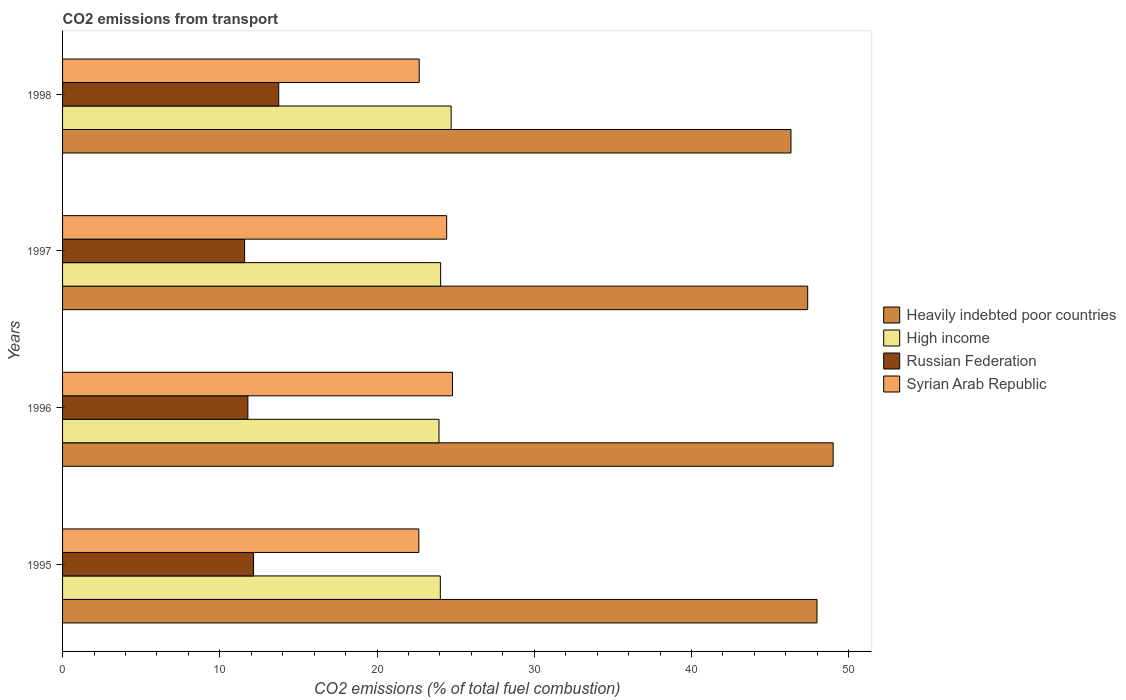How many different coloured bars are there?
Give a very brief answer. 4. Are the number of bars per tick equal to the number of legend labels?
Ensure brevity in your answer.  Yes. Are the number of bars on each tick of the Y-axis equal?
Your answer should be very brief. Yes. What is the label of the 4th group of bars from the top?
Give a very brief answer. 1995. In how many cases, is the number of bars for a given year not equal to the number of legend labels?
Keep it short and to the point. 0. What is the total CO2 emitted in Russian Federation in 1997?
Your answer should be compact. 11.58. Across all years, what is the maximum total CO2 emitted in Russian Federation?
Give a very brief answer. 13.75. Across all years, what is the minimum total CO2 emitted in Syrian Arab Republic?
Your answer should be compact. 22.66. In which year was the total CO2 emitted in High income maximum?
Offer a terse response. 1998. What is the total total CO2 emitted in High income in the graph?
Ensure brevity in your answer.  96.73. What is the difference between the total CO2 emitted in High income in 1995 and that in 1997?
Ensure brevity in your answer.  -0.02. What is the difference between the total CO2 emitted in Syrian Arab Republic in 1998 and the total CO2 emitted in High income in 1995?
Keep it short and to the point. -1.34. What is the average total CO2 emitted in Heavily indebted poor countries per year?
Ensure brevity in your answer.  47.68. In the year 1995, what is the difference between the total CO2 emitted in Syrian Arab Republic and total CO2 emitted in Heavily indebted poor countries?
Ensure brevity in your answer.  -25.33. In how many years, is the total CO2 emitted in Russian Federation greater than 30 ?
Your answer should be compact. 0. What is the ratio of the total CO2 emitted in Syrian Arab Republic in 1995 to that in 1998?
Provide a short and direct response. 1. Is the total CO2 emitted in High income in 1995 less than that in 1996?
Make the answer very short. No. What is the difference between the highest and the second highest total CO2 emitted in High income?
Your response must be concise. 0.67. What is the difference between the highest and the lowest total CO2 emitted in Russian Federation?
Offer a very short reply. 2.17. In how many years, is the total CO2 emitted in Syrian Arab Republic greater than the average total CO2 emitted in Syrian Arab Republic taken over all years?
Provide a succinct answer. 2. Is the sum of the total CO2 emitted in Syrian Arab Republic in 1995 and 1998 greater than the maximum total CO2 emitted in Heavily indebted poor countries across all years?
Make the answer very short. No. What does the 4th bar from the top in 1998 represents?
Your answer should be very brief. Heavily indebted poor countries. What does the 4th bar from the bottom in 1998 represents?
Offer a terse response. Syrian Arab Republic. How many bars are there?
Your response must be concise. 16. Are all the bars in the graph horizontal?
Give a very brief answer. Yes. Are the values on the major ticks of X-axis written in scientific E-notation?
Provide a short and direct response. No. Does the graph contain any zero values?
Ensure brevity in your answer.  No. Does the graph contain grids?
Give a very brief answer. No. Where does the legend appear in the graph?
Keep it short and to the point. Center right. How many legend labels are there?
Your answer should be compact. 4. How are the legend labels stacked?
Keep it short and to the point. Vertical. What is the title of the graph?
Keep it short and to the point. CO2 emissions from transport. Does "Guam" appear as one of the legend labels in the graph?
Provide a short and direct response. No. What is the label or title of the X-axis?
Keep it short and to the point. CO2 emissions (% of total fuel combustion). What is the CO2 emissions (% of total fuel combustion) of Heavily indebted poor countries in 1995?
Provide a short and direct response. 47.99. What is the CO2 emissions (% of total fuel combustion) in High income in 1995?
Your response must be concise. 24.03. What is the CO2 emissions (% of total fuel combustion) of Russian Federation in 1995?
Offer a very short reply. 12.15. What is the CO2 emissions (% of total fuel combustion) in Syrian Arab Republic in 1995?
Offer a terse response. 22.66. What is the CO2 emissions (% of total fuel combustion) of Heavily indebted poor countries in 1996?
Provide a succinct answer. 49.01. What is the CO2 emissions (% of total fuel combustion) in High income in 1996?
Keep it short and to the point. 23.94. What is the CO2 emissions (% of total fuel combustion) in Russian Federation in 1996?
Give a very brief answer. 11.79. What is the CO2 emissions (% of total fuel combustion) in Syrian Arab Republic in 1996?
Provide a short and direct response. 24.8. What is the CO2 emissions (% of total fuel combustion) of Heavily indebted poor countries in 1997?
Make the answer very short. 47.39. What is the CO2 emissions (% of total fuel combustion) in High income in 1997?
Provide a succinct answer. 24.05. What is the CO2 emissions (% of total fuel combustion) of Russian Federation in 1997?
Your answer should be compact. 11.58. What is the CO2 emissions (% of total fuel combustion) in Syrian Arab Republic in 1997?
Keep it short and to the point. 24.43. What is the CO2 emissions (% of total fuel combustion) of Heavily indebted poor countries in 1998?
Offer a very short reply. 46.33. What is the CO2 emissions (% of total fuel combustion) of High income in 1998?
Keep it short and to the point. 24.71. What is the CO2 emissions (% of total fuel combustion) of Russian Federation in 1998?
Provide a succinct answer. 13.75. What is the CO2 emissions (% of total fuel combustion) of Syrian Arab Republic in 1998?
Offer a terse response. 22.68. Across all years, what is the maximum CO2 emissions (% of total fuel combustion) of Heavily indebted poor countries?
Ensure brevity in your answer.  49.01. Across all years, what is the maximum CO2 emissions (% of total fuel combustion) in High income?
Provide a short and direct response. 24.71. Across all years, what is the maximum CO2 emissions (% of total fuel combustion) in Russian Federation?
Your answer should be compact. 13.75. Across all years, what is the maximum CO2 emissions (% of total fuel combustion) in Syrian Arab Republic?
Your answer should be very brief. 24.8. Across all years, what is the minimum CO2 emissions (% of total fuel combustion) in Heavily indebted poor countries?
Your answer should be very brief. 46.33. Across all years, what is the minimum CO2 emissions (% of total fuel combustion) of High income?
Make the answer very short. 23.94. Across all years, what is the minimum CO2 emissions (% of total fuel combustion) in Russian Federation?
Your answer should be compact. 11.58. Across all years, what is the minimum CO2 emissions (% of total fuel combustion) of Syrian Arab Republic?
Ensure brevity in your answer.  22.66. What is the total CO2 emissions (% of total fuel combustion) of Heavily indebted poor countries in the graph?
Give a very brief answer. 190.72. What is the total CO2 emissions (% of total fuel combustion) in High income in the graph?
Your answer should be very brief. 96.73. What is the total CO2 emissions (% of total fuel combustion) in Russian Federation in the graph?
Keep it short and to the point. 49.26. What is the total CO2 emissions (% of total fuel combustion) in Syrian Arab Republic in the graph?
Your response must be concise. 94.58. What is the difference between the CO2 emissions (% of total fuel combustion) of Heavily indebted poor countries in 1995 and that in 1996?
Your response must be concise. -1.03. What is the difference between the CO2 emissions (% of total fuel combustion) of High income in 1995 and that in 1996?
Offer a very short reply. 0.08. What is the difference between the CO2 emissions (% of total fuel combustion) of Russian Federation in 1995 and that in 1996?
Keep it short and to the point. 0.36. What is the difference between the CO2 emissions (% of total fuel combustion) in Syrian Arab Republic in 1995 and that in 1996?
Your answer should be very brief. -2.14. What is the difference between the CO2 emissions (% of total fuel combustion) of Heavily indebted poor countries in 1995 and that in 1997?
Offer a terse response. 0.59. What is the difference between the CO2 emissions (% of total fuel combustion) in High income in 1995 and that in 1997?
Make the answer very short. -0.02. What is the difference between the CO2 emissions (% of total fuel combustion) of Russian Federation in 1995 and that in 1997?
Give a very brief answer. 0.57. What is the difference between the CO2 emissions (% of total fuel combustion) of Syrian Arab Republic in 1995 and that in 1997?
Make the answer very short. -1.77. What is the difference between the CO2 emissions (% of total fuel combustion) of Heavily indebted poor countries in 1995 and that in 1998?
Your response must be concise. 1.66. What is the difference between the CO2 emissions (% of total fuel combustion) in High income in 1995 and that in 1998?
Give a very brief answer. -0.69. What is the difference between the CO2 emissions (% of total fuel combustion) of Russian Federation in 1995 and that in 1998?
Offer a very short reply. -1.6. What is the difference between the CO2 emissions (% of total fuel combustion) in Syrian Arab Republic in 1995 and that in 1998?
Ensure brevity in your answer.  -0.03. What is the difference between the CO2 emissions (% of total fuel combustion) in Heavily indebted poor countries in 1996 and that in 1997?
Your answer should be compact. 1.62. What is the difference between the CO2 emissions (% of total fuel combustion) of High income in 1996 and that in 1997?
Give a very brief answer. -0.1. What is the difference between the CO2 emissions (% of total fuel combustion) of Russian Federation in 1996 and that in 1997?
Offer a terse response. 0.21. What is the difference between the CO2 emissions (% of total fuel combustion) in Syrian Arab Republic in 1996 and that in 1997?
Offer a terse response. 0.37. What is the difference between the CO2 emissions (% of total fuel combustion) in Heavily indebted poor countries in 1996 and that in 1998?
Your answer should be compact. 2.68. What is the difference between the CO2 emissions (% of total fuel combustion) of High income in 1996 and that in 1998?
Keep it short and to the point. -0.77. What is the difference between the CO2 emissions (% of total fuel combustion) in Russian Federation in 1996 and that in 1998?
Ensure brevity in your answer.  -1.96. What is the difference between the CO2 emissions (% of total fuel combustion) of Syrian Arab Republic in 1996 and that in 1998?
Provide a short and direct response. 2.12. What is the difference between the CO2 emissions (% of total fuel combustion) of Heavily indebted poor countries in 1997 and that in 1998?
Keep it short and to the point. 1.06. What is the difference between the CO2 emissions (% of total fuel combustion) of High income in 1997 and that in 1998?
Make the answer very short. -0.67. What is the difference between the CO2 emissions (% of total fuel combustion) in Russian Federation in 1997 and that in 1998?
Offer a very short reply. -2.17. What is the difference between the CO2 emissions (% of total fuel combustion) of Syrian Arab Republic in 1997 and that in 1998?
Your answer should be very brief. 1.75. What is the difference between the CO2 emissions (% of total fuel combustion) in Heavily indebted poor countries in 1995 and the CO2 emissions (% of total fuel combustion) in High income in 1996?
Provide a succinct answer. 24.04. What is the difference between the CO2 emissions (% of total fuel combustion) of Heavily indebted poor countries in 1995 and the CO2 emissions (% of total fuel combustion) of Russian Federation in 1996?
Your response must be concise. 36.2. What is the difference between the CO2 emissions (% of total fuel combustion) in Heavily indebted poor countries in 1995 and the CO2 emissions (% of total fuel combustion) in Syrian Arab Republic in 1996?
Offer a terse response. 23.18. What is the difference between the CO2 emissions (% of total fuel combustion) in High income in 1995 and the CO2 emissions (% of total fuel combustion) in Russian Federation in 1996?
Provide a succinct answer. 12.24. What is the difference between the CO2 emissions (% of total fuel combustion) in High income in 1995 and the CO2 emissions (% of total fuel combustion) in Syrian Arab Republic in 1996?
Your answer should be very brief. -0.77. What is the difference between the CO2 emissions (% of total fuel combustion) in Russian Federation in 1995 and the CO2 emissions (% of total fuel combustion) in Syrian Arab Republic in 1996?
Offer a terse response. -12.65. What is the difference between the CO2 emissions (% of total fuel combustion) of Heavily indebted poor countries in 1995 and the CO2 emissions (% of total fuel combustion) of High income in 1997?
Keep it short and to the point. 23.94. What is the difference between the CO2 emissions (% of total fuel combustion) of Heavily indebted poor countries in 1995 and the CO2 emissions (% of total fuel combustion) of Russian Federation in 1997?
Make the answer very short. 36.41. What is the difference between the CO2 emissions (% of total fuel combustion) of Heavily indebted poor countries in 1995 and the CO2 emissions (% of total fuel combustion) of Syrian Arab Republic in 1997?
Your answer should be compact. 23.55. What is the difference between the CO2 emissions (% of total fuel combustion) of High income in 1995 and the CO2 emissions (% of total fuel combustion) of Russian Federation in 1997?
Your response must be concise. 12.45. What is the difference between the CO2 emissions (% of total fuel combustion) in High income in 1995 and the CO2 emissions (% of total fuel combustion) in Syrian Arab Republic in 1997?
Offer a terse response. -0.4. What is the difference between the CO2 emissions (% of total fuel combustion) of Russian Federation in 1995 and the CO2 emissions (% of total fuel combustion) of Syrian Arab Republic in 1997?
Provide a succinct answer. -12.28. What is the difference between the CO2 emissions (% of total fuel combustion) of Heavily indebted poor countries in 1995 and the CO2 emissions (% of total fuel combustion) of High income in 1998?
Provide a short and direct response. 23.27. What is the difference between the CO2 emissions (% of total fuel combustion) in Heavily indebted poor countries in 1995 and the CO2 emissions (% of total fuel combustion) in Russian Federation in 1998?
Your answer should be very brief. 34.24. What is the difference between the CO2 emissions (% of total fuel combustion) of Heavily indebted poor countries in 1995 and the CO2 emissions (% of total fuel combustion) of Syrian Arab Republic in 1998?
Your answer should be compact. 25.3. What is the difference between the CO2 emissions (% of total fuel combustion) of High income in 1995 and the CO2 emissions (% of total fuel combustion) of Russian Federation in 1998?
Offer a terse response. 10.28. What is the difference between the CO2 emissions (% of total fuel combustion) in High income in 1995 and the CO2 emissions (% of total fuel combustion) in Syrian Arab Republic in 1998?
Offer a terse response. 1.34. What is the difference between the CO2 emissions (% of total fuel combustion) of Russian Federation in 1995 and the CO2 emissions (% of total fuel combustion) of Syrian Arab Republic in 1998?
Ensure brevity in your answer.  -10.54. What is the difference between the CO2 emissions (% of total fuel combustion) of Heavily indebted poor countries in 1996 and the CO2 emissions (% of total fuel combustion) of High income in 1997?
Offer a very short reply. 24.97. What is the difference between the CO2 emissions (% of total fuel combustion) of Heavily indebted poor countries in 1996 and the CO2 emissions (% of total fuel combustion) of Russian Federation in 1997?
Provide a succinct answer. 37.43. What is the difference between the CO2 emissions (% of total fuel combustion) in Heavily indebted poor countries in 1996 and the CO2 emissions (% of total fuel combustion) in Syrian Arab Republic in 1997?
Provide a succinct answer. 24.58. What is the difference between the CO2 emissions (% of total fuel combustion) of High income in 1996 and the CO2 emissions (% of total fuel combustion) of Russian Federation in 1997?
Make the answer very short. 12.36. What is the difference between the CO2 emissions (% of total fuel combustion) in High income in 1996 and the CO2 emissions (% of total fuel combustion) in Syrian Arab Republic in 1997?
Offer a terse response. -0.49. What is the difference between the CO2 emissions (% of total fuel combustion) of Russian Federation in 1996 and the CO2 emissions (% of total fuel combustion) of Syrian Arab Republic in 1997?
Give a very brief answer. -12.64. What is the difference between the CO2 emissions (% of total fuel combustion) in Heavily indebted poor countries in 1996 and the CO2 emissions (% of total fuel combustion) in High income in 1998?
Your answer should be compact. 24.3. What is the difference between the CO2 emissions (% of total fuel combustion) in Heavily indebted poor countries in 1996 and the CO2 emissions (% of total fuel combustion) in Russian Federation in 1998?
Provide a short and direct response. 35.26. What is the difference between the CO2 emissions (% of total fuel combustion) of Heavily indebted poor countries in 1996 and the CO2 emissions (% of total fuel combustion) of Syrian Arab Republic in 1998?
Provide a succinct answer. 26.33. What is the difference between the CO2 emissions (% of total fuel combustion) in High income in 1996 and the CO2 emissions (% of total fuel combustion) in Russian Federation in 1998?
Keep it short and to the point. 10.19. What is the difference between the CO2 emissions (% of total fuel combustion) in High income in 1996 and the CO2 emissions (% of total fuel combustion) in Syrian Arab Republic in 1998?
Your answer should be compact. 1.26. What is the difference between the CO2 emissions (% of total fuel combustion) of Russian Federation in 1996 and the CO2 emissions (% of total fuel combustion) of Syrian Arab Republic in 1998?
Offer a terse response. -10.9. What is the difference between the CO2 emissions (% of total fuel combustion) of Heavily indebted poor countries in 1997 and the CO2 emissions (% of total fuel combustion) of High income in 1998?
Ensure brevity in your answer.  22.68. What is the difference between the CO2 emissions (% of total fuel combustion) in Heavily indebted poor countries in 1997 and the CO2 emissions (% of total fuel combustion) in Russian Federation in 1998?
Offer a terse response. 33.64. What is the difference between the CO2 emissions (% of total fuel combustion) in Heavily indebted poor countries in 1997 and the CO2 emissions (% of total fuel combustion) in Syrian Arab Republic in 1998?
Your answer should be very brief. 24.71. What is the difference between the CO2 emissions (% of total fuel combustion) in High income in 1997 and the CO2 emissions (% of total fuel combustion) in Russian Federation in 1998?
Ensure brevity in your answer.  10.3. What is the difference between the CO2 emissions (% of total fuel combustion) of High income in 1997 and the CO2 emissions (% of total fuel combustion) of Syrian Arab Republic in 1998?
Make the answer very short. 1.36. What is the difference between the CO2 emissions (% of total fuel combustion) in Russian Federation in 1997 and the CO2 emissions (% of total fuel combustion) in Syrian Arab Republic in 1998?
Keep it short and to the point. -11.11. What is the average CO2 emissions (% of total fuel combustion) in Heavily indebted poor countries per year?
Offer a very short reply. 47.68. What is the average CO2 emissions (% of total fuel combustion) in High income per year?
Give a very brief answer. 24.18. What is the average CO2 emissions (% of total fuel combustion) in Russian Federation per year?
Offer a terse response. 12.32. What is the average CO2 emissions (% of total fuel combustion) of Syrian Arab Republic per year?
Keep it short and to the point. 23.64. In the year 1995, what is the difference between the CO2 emissions (% of total fuel combustion) in Heavily indebted poor countries and CO2 emissions (% of total fuel combustion) in High income?
Give a very brief answer. 23.96. In the year 1995, what is the difference between the CO2 emissions (% of total fuel combustion) in Heavily indebted poor countries and CO2 emissions (% of total fuel combustion) in Russian Federation?
Provide a short and direct response. 35.84. In the year 1995, what is the difference between the CO2 emissions (% of total fuel combustion) of Heavily indebted poor countries and CO2 emissions (% of total fuel combustion) of Syrian Arab Republic?
Provide a succinct answer. 25.33. In the year 1995, what is the difference between the CO2 emissions (% of total fuel combustion) of High income and CO2 emissions (% of total fuel combustion) of Russian Federation?
Your answer should be compact. 11.88. In the year 1995, what is the difference between the CO2 emissions (% of total fuel combustion) of High income and CO2 emissions (% of total fuel combustion) of Syrian Arab Republic?
Make the answer very short. 1.37. In the year 1995, what is the difference between the CO2 emissions (% of total fuel combustion) of Russian Federation and CO2 emissions (% of total fuel combustion) of Syrian Arab Republic?
Provide a short and direct response. -10.51. In the year 1996, what is the difference between the CO2 emissions (% of total fuel combustion) in Heavily indebted poor countries and CO2 emissions (% of total fuel combustion) in High income?
Make the answer very short. 25.07. In the year 1996, what is the difference between the CO2 emissions (% of total fuel combustion) of Heavily indebted poor countries and CO2 emissions (% of total fuel combustion) of Russian Federation?
Keep it short and to the point. 37.23. In the year 1996, what is the difference between the CO2 emissions (% of total fuel combustion) in Heavily indebted poor countries and CO2 emissions (% of total fuel combustion) in Syrian Arab Republic?
Give a very brief answer. 24.21. In the year 1996, what is the difference between the CO2 emissions (% of total fuel combustion) of High income and CO2 emissions (% of total fuel combustion) of Russian Federation?
Your response must be concise. 12.16. In the year 1996, what is the difference between the CO2 emissions (% of total fuel combustion) in High income and CO2 emissions (% of total fuel combustion) in Syrian Arab Republic?
Keep it short and to the point. -0.86. In the year 1996, what is the difference between the CO2 emissions (% of total fuel combustion) in Russian Federation and CO2 emissions (% of total fuel combustion) in Syrian Arab Republic?
Offer a terse response. -13.01. In the year 1997, what is the difference between the CO2 emissions (% of total fuel combustion) of Heavily indebted poor countries and CO2 emissions (% of total fuel combustion) of High income?
Give a very brief answer. 23.35. In the year 1997, what is the difference between the CO2 emissions (% of total fuel combustion) in Heavily indebted poor countries and CO2 emissions (% of total fuel combustion) in Russian Federation?
Provide a succinct answer. 35.81. In the year 1997, what is the difference between the CO2 emissions (% of total fuel combustion) of Heavily indebted poor countries and CO2 emissions (% of total fuel combustion) of Syrian Arab Republic?
Ensure brevity in your answer.  22.96. In the year 1997, what is the difference between the CO2 emissions (% of total fuel combustion) of High income and CO2 emissions (% of total fuel combustion) of Russian Federation?
Keep it short and to the point. 12.47. In the year 1997, what is the difference between the CO2 emissions (% of total fuel combustion) in High income and CO2 emissions (% of total fuel combustion) in Syrian Arab Republic?
Offer a terse response. -0.39. In the year 1997, what is the difference between the CO2 emissions (% of total fuel combustion) of Russian Federation and CO2 emissions (% of total fuel combustion) of Syrian Arab Republic?
Your response must be concise. -12.85. In the year 1998, what is the difference between the CO2 emissions (% of total fuel combustion) of Heavily indebted poor countries and CO2 emissions (% of total fuel combustion) of High income?
Provide a short and direct response. 21.62. In the year 1998, what is the difference between the CO2 emissions (% of total fuel combustion) of Heavily indebted poor countries and CO2 emissions (% of total fuel combustion) of Russian Federation?
Give a very brief answer. 32.58. In the year 1998, what is the difference between the CO2 emissions (% of total fuel combustion) of Heavily indebted poor countries and CO2 emissions (% of total fuel combustion) of Syrian Arab Republic?
Your answer should be very brief. 23.64. In the year 1998, what is the difference between the CO2 emissions (% of total fuel combustion) in High income and CO2 emissions (% of total fuel combustion) in Russian Federation?
Ensure brevity in your answer.  10.97. In the year 1998, what is the difference between the CO2 emissions (% of total fuel combustion) of High income and CO2 emissions (% of total fuel combustion) of Syrian Arab Republic?
Offer a very short reply. 2.03. In the year 1998, what is the difference between the CO2 emissions (% of total fuel combustion) in Russian Federation and CO2 emissions (% of total fuel combustion) in Syrian Arab Republic?
Give a very brief answer. -8.94. What is the ratio of the CO2 emissions (% of total fuel combustion) in Heavily indebted poor countries in 1995 to that in 1996?
Provide a succinct answer. 0.98. What is the ratio of the CO2 emissions (% of total fuel combustion) in Russian Federation in 1995 to that in 1996?
Provide a short and direct response. 1.03. What is the ratio of the CO2 emissions (% of total fuel combustion) of Syrian Arab Republic in 1995 to that in 1996?
Ensure brevity in your answer.  0.91. What is the ratio of the CO2 emissions (% of total fuel combustion) of Heavily indebted poor countries in 1995 to that in 1997?
Your response must be concise. 1.01. What is the ratio of the CO2 emissions (% of total fuel combustion) of High income in 1995 to that in 1997?
Give a very brief answer. 1. What is the ratio of the CO2 emissions (% of total fuel combustion) in Russian Federation in 1995 to that in 1997?
Keep it short and to the point. 1.05. What is the ratio of the CO2 emissions (% of total fuel combustion) of Syrian Arab Republic in 1995 to that in 1997?
Your response must be concise. 0.93. What is the ratio of the CO2 emissions (% of total fuel combustion) of Heavily indebted poor countries in 1995 to that in 1998?
Provide a succinct answer. 1.04. What is the ratio of the CO2 emissions (% of total fuel combustion) of High income in 1995 to that in 1998?
Offer a very short reply. 0.97. What is the ratio of the CO2 emissions (% of total fuel combustion) of Russian Federation in 1995 to that in 1998?
Your response must be concise. 0.88. What is the ratio of the CO2 emissions (% of total fuel combustion) of Heavily indebted poor countries in 1996 to that in 1997?
Keep it short and to the point. 1.03. What is the ratio of the CO2 emissions (% of total fuel combustion) in High income in 1996 to that in 1997?
Your answer should be compact. 1. What is the ratio of the CO2 emissions (% of total fuel combustion) in Russian Federation in 1996 to that in 1997?
Ensure brevity in your answer.  1.02. What is the ratio of the CO2 emissions (% of total fuel combustion) in Syrian Arab Republic in 1996 to that in 1997?
Your answer should be very brief. 1.02. What is the ratio of the CO2 emissions (% of total fuel combustion) of Heavily indebted poor countries in 1996 to that in 1998?
Provide a succinct answer. 1.06. What is the ratio of the CO2 emissions (% of total fuel combustion) of High income in 1996 to that in 1998?
Keep it short and to the point. 0.97. What is the ratio of the CO2 emissions (% of total fuel combustion) in Russian Federation in 1996 to that in 1998?
Ensure brevity in your answer.  0.86. What is the ratio of the CO2 emissions (% of total fuel combustion) in Syrian Arab Republic in 1996 to that in 1998?
Offer a terse response. 1.09. What is the ratio of the CO2 emissions (% of total fuel combustion) in High income in 1997 to that in 1998?
Your answer should be compact. 0.97. What is the ratio of the CO2 emissions (% of total fuel combustion) of Russian Federation in 1997 to that in 1998?
Your answer should be compact. 0.84. What is the ratio of the CO2 emissions (% of total fuel combustion) in Syrian Arab Republic in 1997 to that in 1998?
Your response must be concise. 1.08. What is the difference between the highest and the second highest CO2 emissions (% of total fuel combustion) of Heavily indebted poor countries?
Make the answer very short. 1.03. What is the difference between the highest and the second highest CO2 emissions (% of total fuel combustion) in High income?
Offer a very short reply. 0.67. What is the difference between the highest and the second highest CO2 emissions (% of total fuel combustion) of Russian Federation?
Make the answer very short. 1.6. What is the difference between the highest and the second highest CO2 emissions (% of total fuel combustion) in Syrian Arab Republic?
Offer a terse response. 0.37. What is the difference between the highest and the lowest CO2 emissions (% of total fuel combustion) of Heavily indebted poor countries?
Give a very brief answer. 2.68. What is the difference between the highest and the lowest CO2 emissions (% of total fuel combustion) in High income?
Make the answer very short. 0.77. What is the difference between the highest and the lowest CO2 emissions (% of total fuel combustion) of Russian Federation?
Provide a succinct answer. 2.17. What is the difference between the highest and the lowest CO2 emissions (% of total fuel combustion) in Syrian Arab Republic?
Provide a short and direct response. 2.14. 